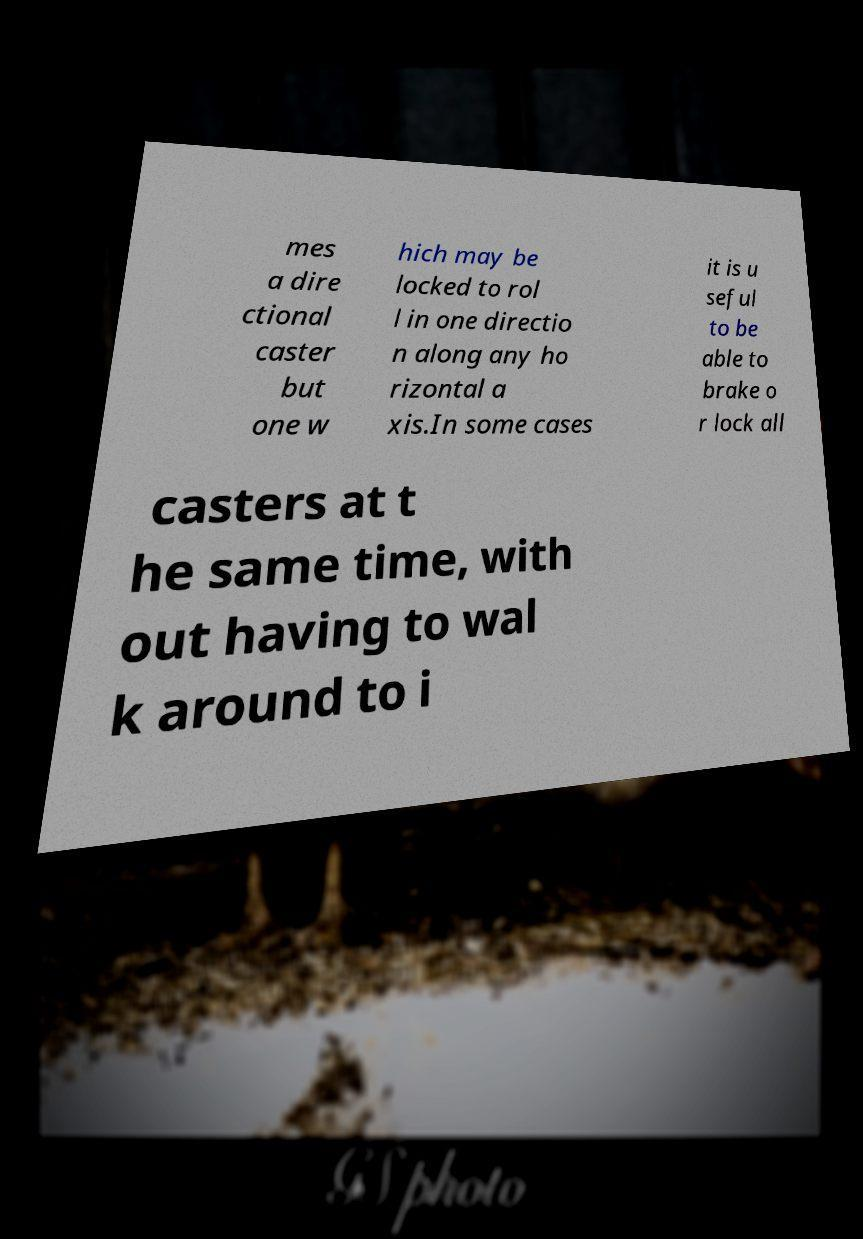There's text embedded in this image that I need extracted. Can you transcribe it verbatim? mes a dire ctional caster but one w hich may be locked to rol l in one directio n along any ho rizontal a xis.In some cases it is u seful to be able to brake o r lock all casters at t he same time, with out having to wal k around to i 